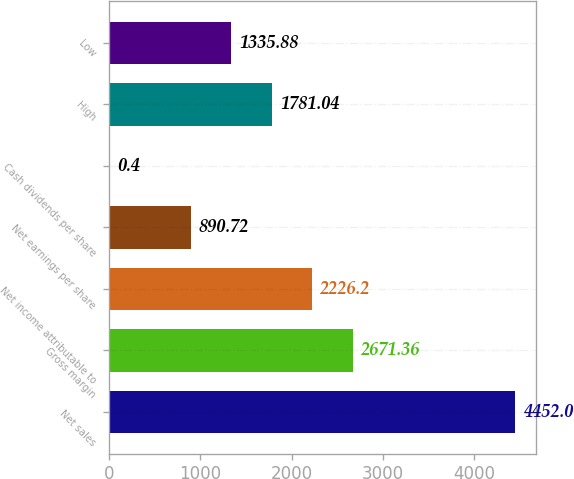Convert chart to OTSL. <chart><loc_0><loc_0><loc_500><loc_500><bar_chart><fcel>Net sales<fcel>Gross margin<fcel>Net income attributable to<fcel>Net earnings per share<fcel>Cash dividends per share<fcel>High<fcel>Low<nl><fcel>4452<fcel>2671.36<fcel>2226.2<fcel>890.72<fcel>0.4<fcel>1781.04<fcel>1335.88<nl></chart> 